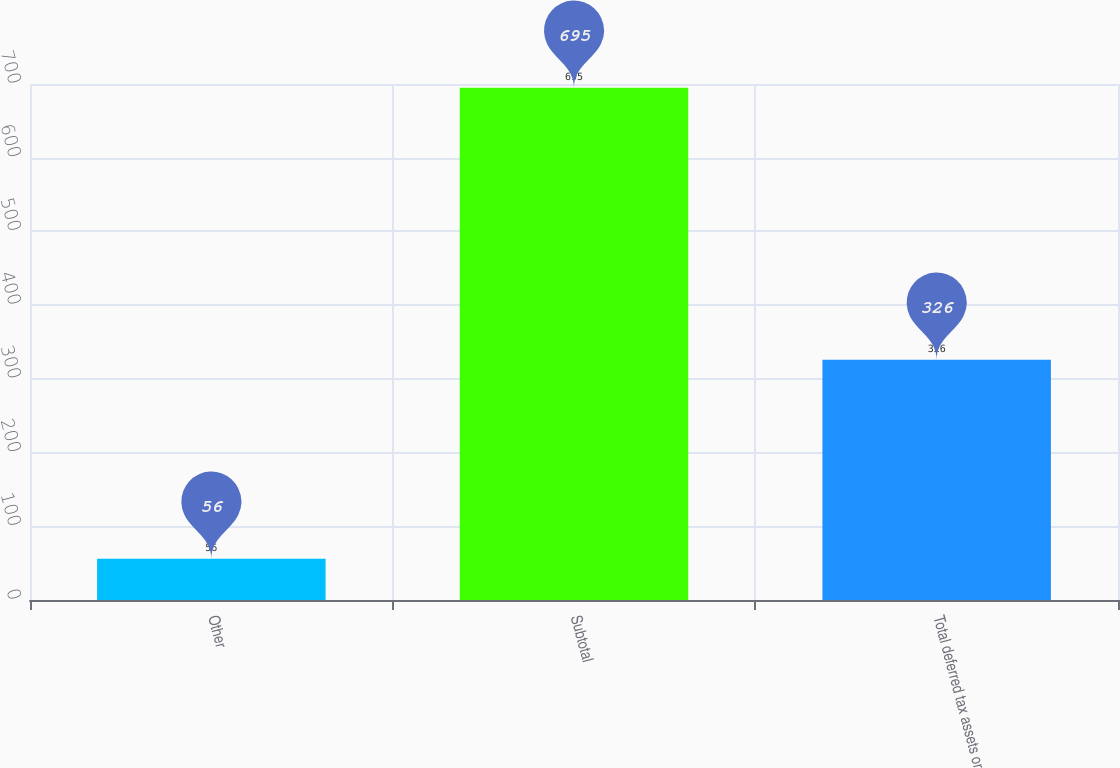<chart> <loc_0><loc_0><loc_500><loc_500><bar_chart><fcel>Other<fcel>Subtotal<fcel>Total deferred tax assets or<nl><fcel>56<fcel>695<fcel>326<nl></chart> 